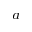Convert formula to latex. <formula><loc_0><loc_0><loc_500><loc_500>^ { a }</formula> 